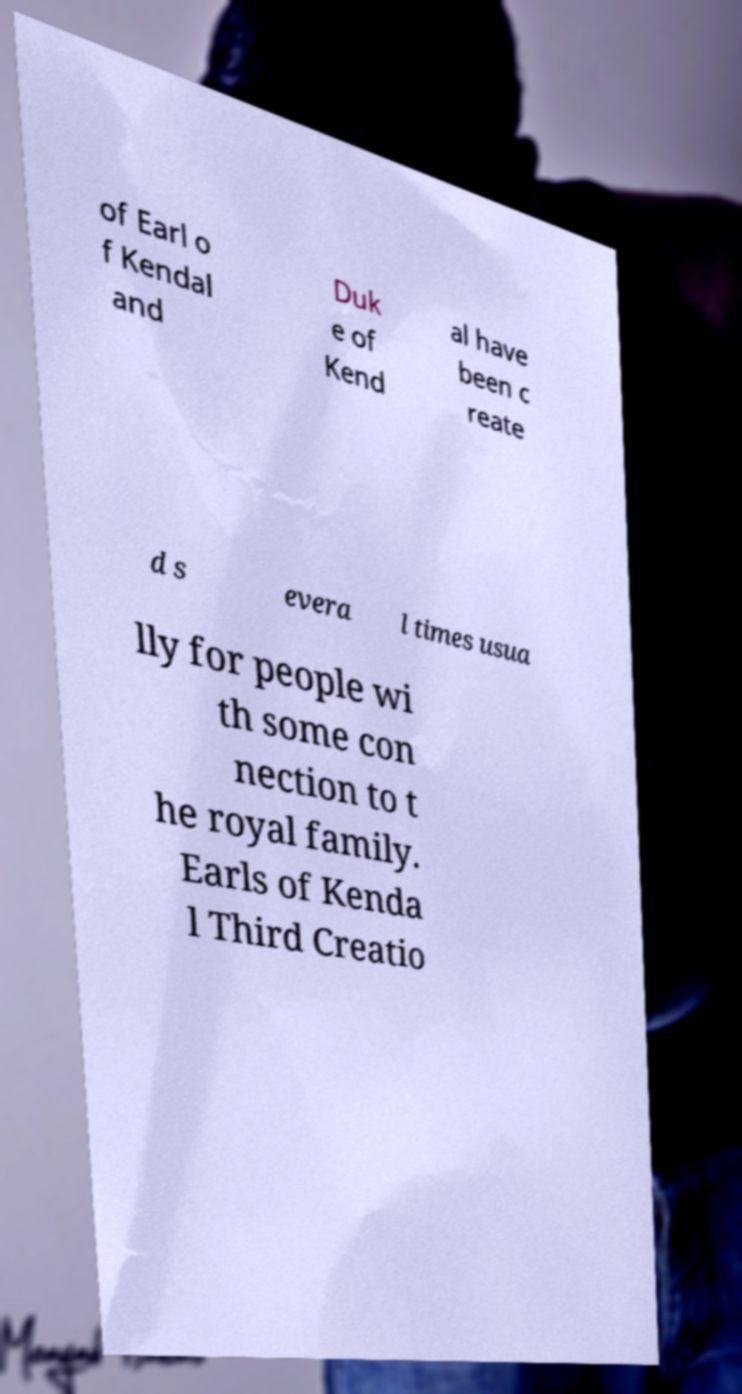Please read and relay the text visible in this image. What does it say? of Earl o f Kendal and Duk e of Kend al have been c reate d s evera l times usua lly for people wi th some con nection to t he royal family. Earls of Kenda l Third Creatio 